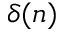<formula> <loc_0><loc_0><loc_500><loc_500>\delta ( n )</formula> 